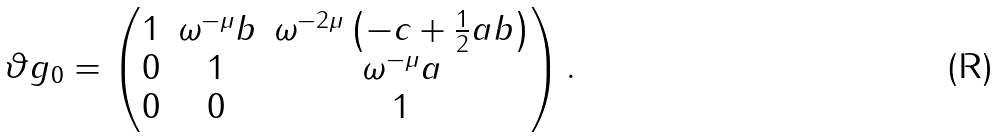Convert formula to latex. <formula><loc_0><loc_0><loc_500><loc_500>\vartheta g _ { 0 } = \begin{pmatrix} 1 & \omega ^ { - \mu } b & \omega ^ { - 2 \mu } \left ( - c + \frac { 1 } { 2 } a b \right ) \\ 0 & 1 & \omega ^ { - \mu } a \\ 0 & 0 & 1 \end{pmatrix} .</formula> 